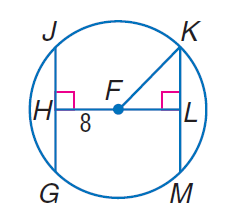Answer the mathemtical geometry problem and directly provide the correct option letter.
Question: In \odot F, F H \cong F L and F K = 17. Find K M.
Choices: A: 8 B: 15 C: 17 D: 30 D 